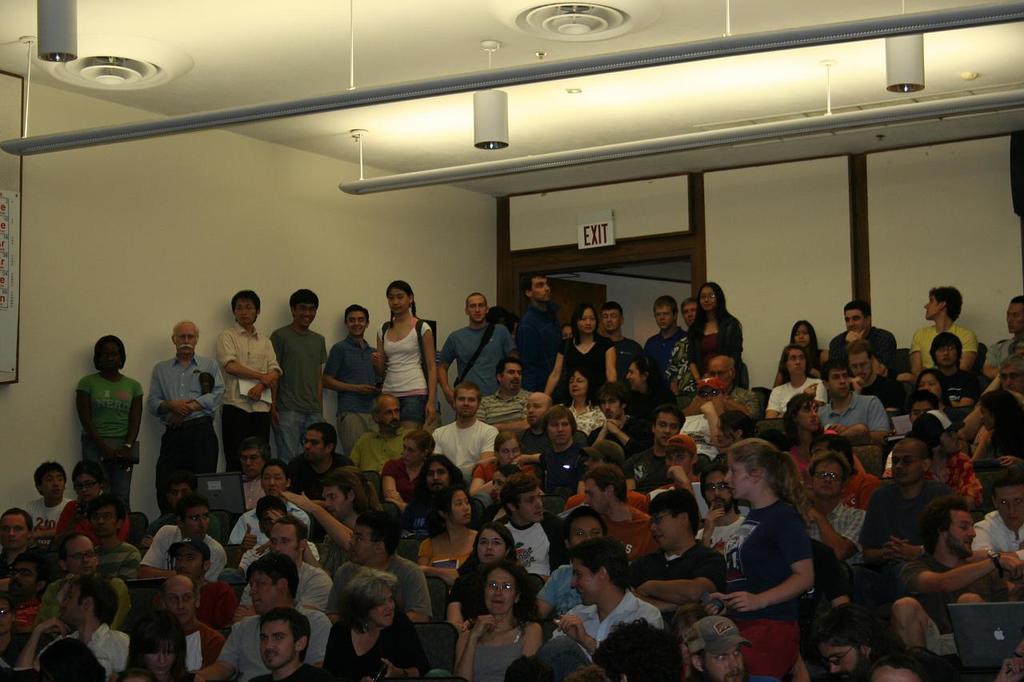In one or two sentences, can you explain what this image depicts? This image is clicked inside the hall. In this image we can see that there are so many people who are sitting in the chairs. While some people are standing beside them. At the top there is ceiling with the lights. In the background there is a door. Above the door there is an exit board. On the left side there is a board. 